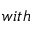<formula> <loc_0><loc_0><loc_500><loc_500>w i t h</formula> 